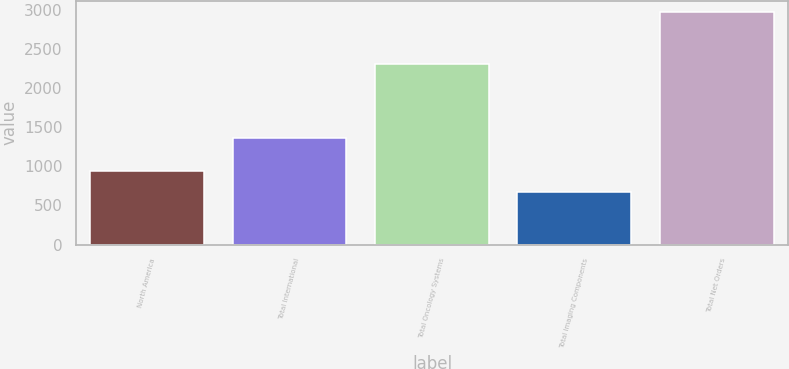<chart> <loc_0><loc_0><loc_500><loc_500><bar_chart><fcel>North America<fcel>Total International<fcel>Total Oncology Systems<fcel>Total Imaging Components<fcel>Total Net Orders<nl><fcel>938.9<fcel>1360.1<fcel>2299<fcel>665.9<fcel>2967.5<nl></chart> 